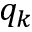<formula> <loc_0><loc_0><loc_500><loc_500>q _ { k }</formula> 